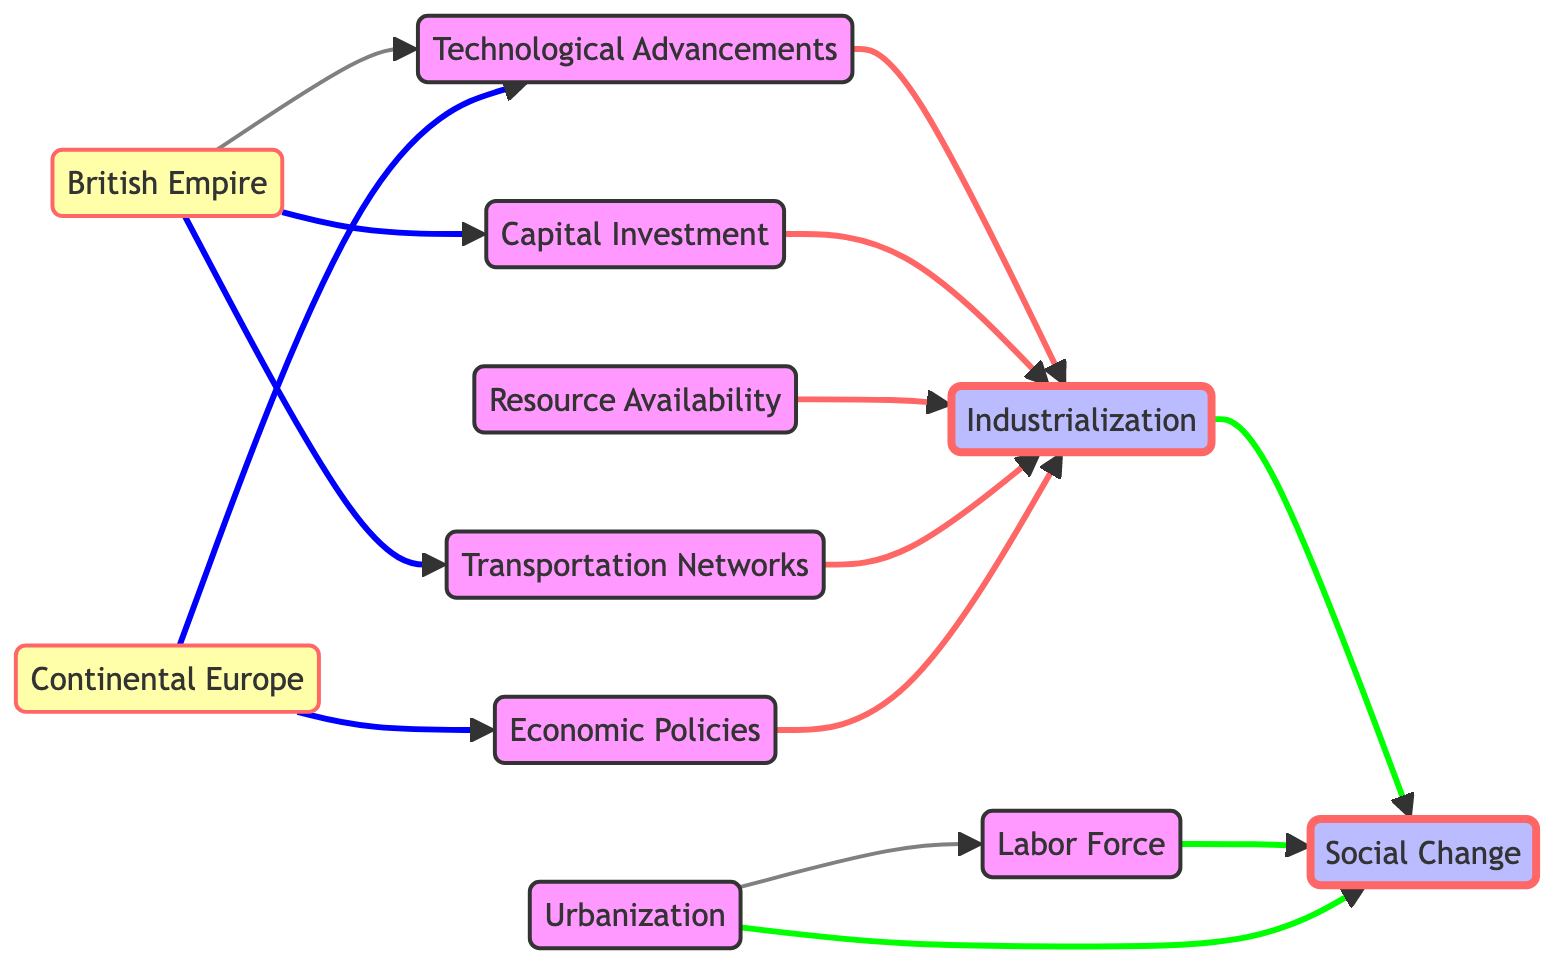What's the number of nodes in the diagram? The diagram contains a total of 11 nodes, which are the individual elements labeled from Industrialization to Social Change, including all contributing factors.
Answer: 11 Which node directly influences Industrialization the most? The Technological Advancements node is directly linked to Industrialization by one edge, indicating it has a direct influence on the process of Industrialization.
Answer: Technological Advancements How many edges are leading into Social Change? There are three edges leading into the Social Change node; those edges come from Industrialization, Labor Force, and Urbanization, demonstrating multiple influences on social changes during that period.
Answer: 3 What are the two nodes connected directly to British Empire? The British Empire has direct connections to Technological Advancements and Capital Investment through the directed edges that flow from the British Empire to these nodes, signifying its role in fostering these developments.
Answer: Technological Advancements, Capital Investment Which nodes represent factors associated with Labor Force? The Labor Force node is influenced primarily by Urbanization, which indicates that increased urbanization led to a larger labor force, thus playing a vital role in the industrial process.
Answer: Urbanization What is the relationship between Economic Policies and Industrialization? Economic Policies directly influence Industrialization as represented by the one edge flowing from Economic Policies to Industrialization, indicating a significant connection to the industrial growth in Europe.
Answer: Influence How many nodes are influenced by the British Empire? The British Empire influences three nodes: Technological Advancements, Capital Investment, and Transportation Networks, showcasing its integral role in advancing industrialization and infrastructure development.
Answer: 3 What does the node Resource Availability influence? Resource Availability directly influences the Industrialization node, suggesting that the availability of resources was a key factor in the industrial growth of the period.
Answer: Industrialization What type of change is represented by the Social Change node? The Social Change node reflects the diverse impacts of Industrialization and demographic changes such as Labor Force and Urbanization, leading to significant shifts in social structures and norms during the 19th century.
Answer: Changes 